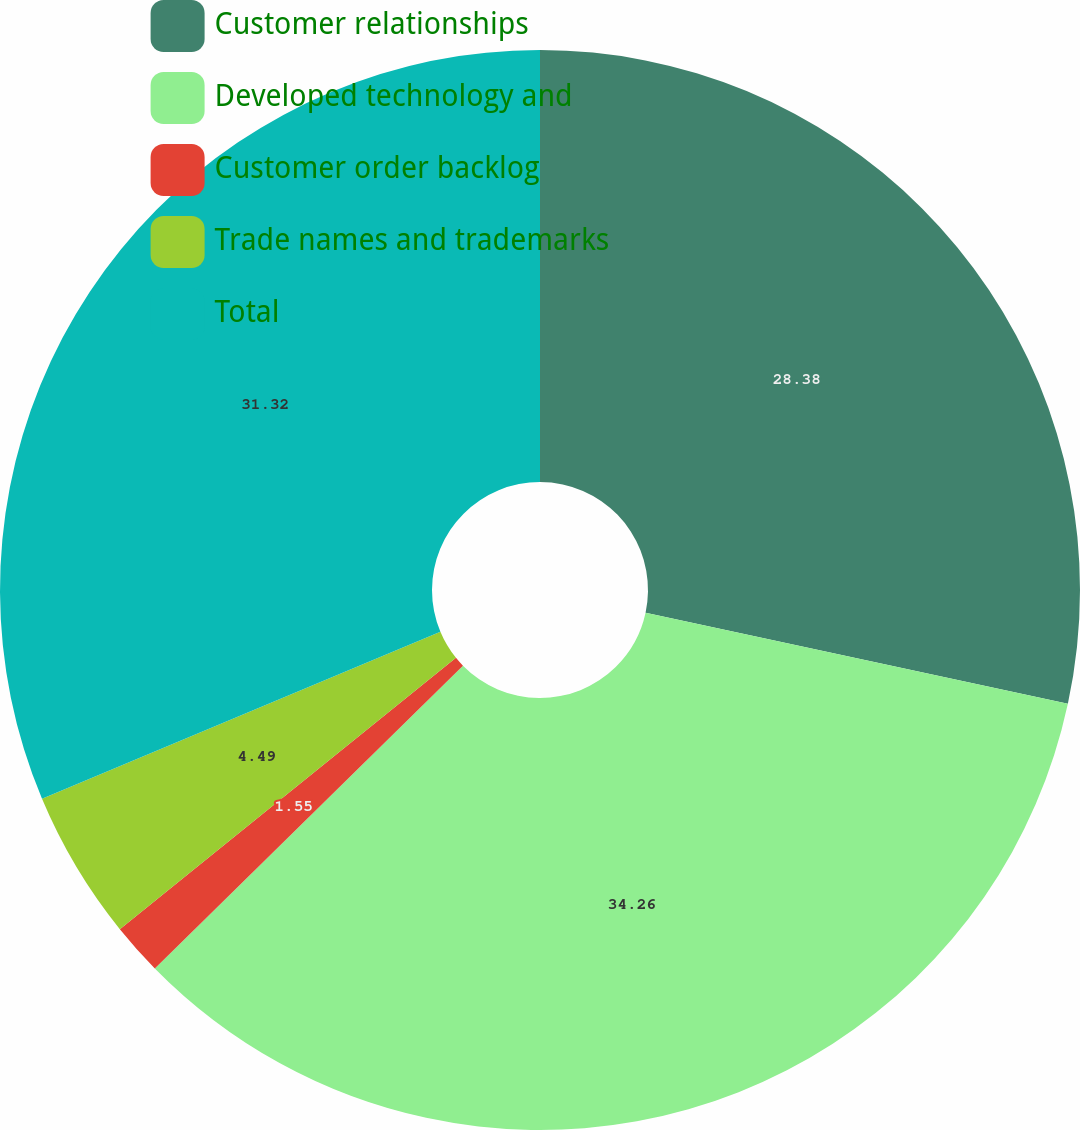Convert chart. <chart><loc_0><loc_0><loc_500><loc_500><pie_chart><fcel>Customer relationships<fcel>Developed technology and<fcel>Customer order backlog<fcel>Trade names and trademarks<fcel>Total<nl><fcel>28.38%<fcel>34.26%<fcel>1.55%<fcel>4.49%<fcel>31.32%<nl></chart> 